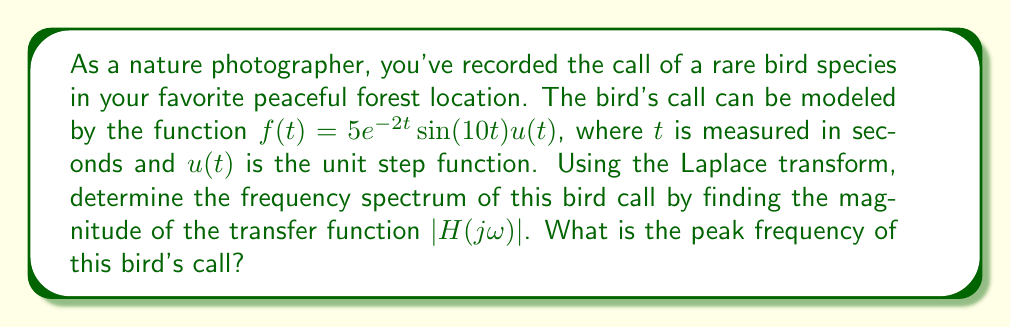Give your solution to this math problem. Let's approach this step-by-step:

1) First, we need to find the Laplace transform of $f(t)$. The Laplace transform of $5e^{-2t}\sin(10t)u(t)$ is:

   $$F(s) = \frac{5 \cdot 10}{(s+2)^2 + 10^2}$$

2) To find the frequency response, we replace $s$ with $j\omega$:

   $$H(j\omega) = \frac{50}{(j\omega+2)^2 + 100}$$

3) To find the magnitude of the transfer function, we calculate:

   $$|H(j\omega)| = \left|\frac{50}{(j\omega+2)^2 + 100}\right| = \frac{50}{\sqrt{(\omega^2-104)^2 + 16\omega^2}}$$

4) To find the peak frequency, we need to find the maximum of $|H(j\omega)|$. This occurs when the denominator is at its minimum. Let's differentiate the denominator with respect to $\omega$ and set it to zero:

   $$\frac{d}{d\omega}[(\omega^2-104)^2 + 16\omega^2] = 4\omega(\omega^2-104) + 32\omega = 4\omega(\omega^2-98) = 0$$

5) Solving this equation:
   $\omega = 0$ or $\omega^2 = 98$
   
   $\omega = 0$ gives a minimum, so the maximum occurs at $\omega = \sqrt{98} = 7\sqrt{2}$ rad/s

6) To convert this to Hz, we divide by $2\pi$:

   $$f_{peak} = \frac{7\sqrt{2}}{2\pi} \approx 1.57 \text{ Hz}$$

This peak frequency represents the dominant frequency in the bird's call, which could be used for species identification.
Answer: The peak frequency of the bird's call is approximately 1.57 Hz. 